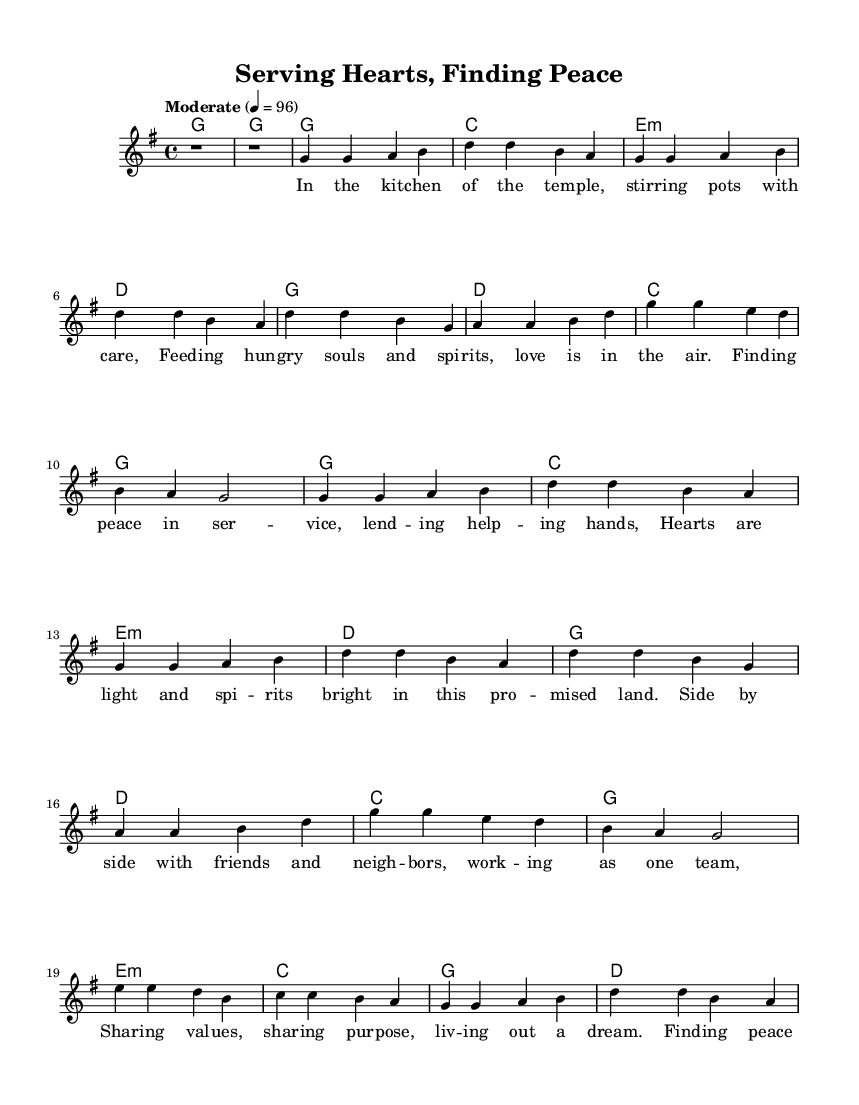What is the key signature of this music? The key signature is G major, which has one sharp (F#). This can be identified from the `\key g \major` line in the global section.
Answer: G major What is the time signature of this music? The time signature is 4/4, indicating four beats in each measure and a quarter note gets one beat. This is indicated by the `\time 4/4` line in the global section.
Answer: 4/4 What is the tempo marking for the piece? The tempo marking is "Moderate" set to a quarter note equals 96 beats per minute, indicated in the `\tempo "Moderate" 4 = 96` section.
Answer: Moderate 4 = 96 How many verses are present in the piece? There are two verses, labeled as Verse 1 and Verse 2 in the lyrics section of the `\lyricmode` configuration. Each verse is distinct and sequential in the lyrics layout.
Answer: 2 What musical form does the piece predominantly follow? The piece follows a verse-chorus structure, alternating between verses and choruses, with a bridge interposed, which is typical in country music. This can be seen in the arrangement of the lyrics and melody blocks.
Answer: Verse-Chorus What is the first line of the chorus? The first line of the chorus is "Finding peace in service, lending helping hands," as represented in the `\lyricmode` for the chorus section.
Answer: Finding peace in service, lending helping hands What is the purpose of the bridge in this piece? The purpose of the bridge, which contains different lyrics than the verses and chorus, is to provide contrast and emotional depth to the song before returning to the chorus. This is a common feature in country anthems to enhance the narrative.
Answer: Emotional contrast 